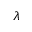<formula> <loc_0><loc_0><loc_500><loc_500>\lambda</formula> 